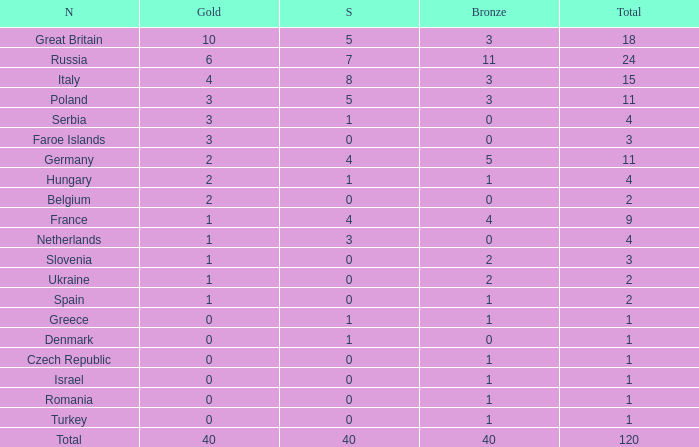What is Turkey's average Gold entry that also has a Bronze entry that is smaller than 2 and the Total is greater than 1? None. 